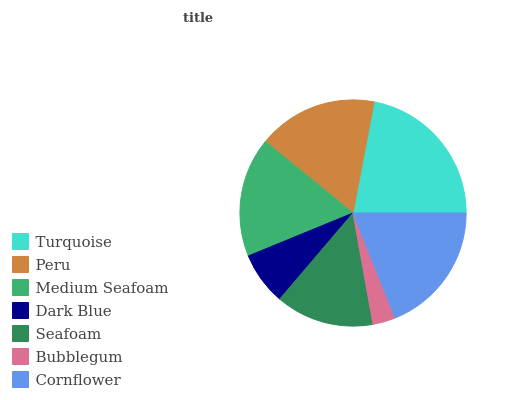Is Bubblegum the minimum?
Answer yes or no. Yes. Is Turquoise the maximum?
Answer yes or no. Yes. Is Peru the minimum?
Answer yes or no. No. Is Peru the maximum?
Answer yes or no. No. Is Turquoise greater than Peru?
Answer yes or no. Yes. Is Peru less than Turquoise?
Answer yes or no. Yes. Is Peru greater than Turquoise?
Answer yes or no. No. Is Turquoise less than Peru?
Answer yes or no. No. Is Peru the high median?
Answer yes or no. Yes. Is Peru the low median?
Answer yes or no. Yes. Is Turquoise the high median?
Answer yes or no. No. Is Medium Seafoam the low median?
Answer yes or no. No. 